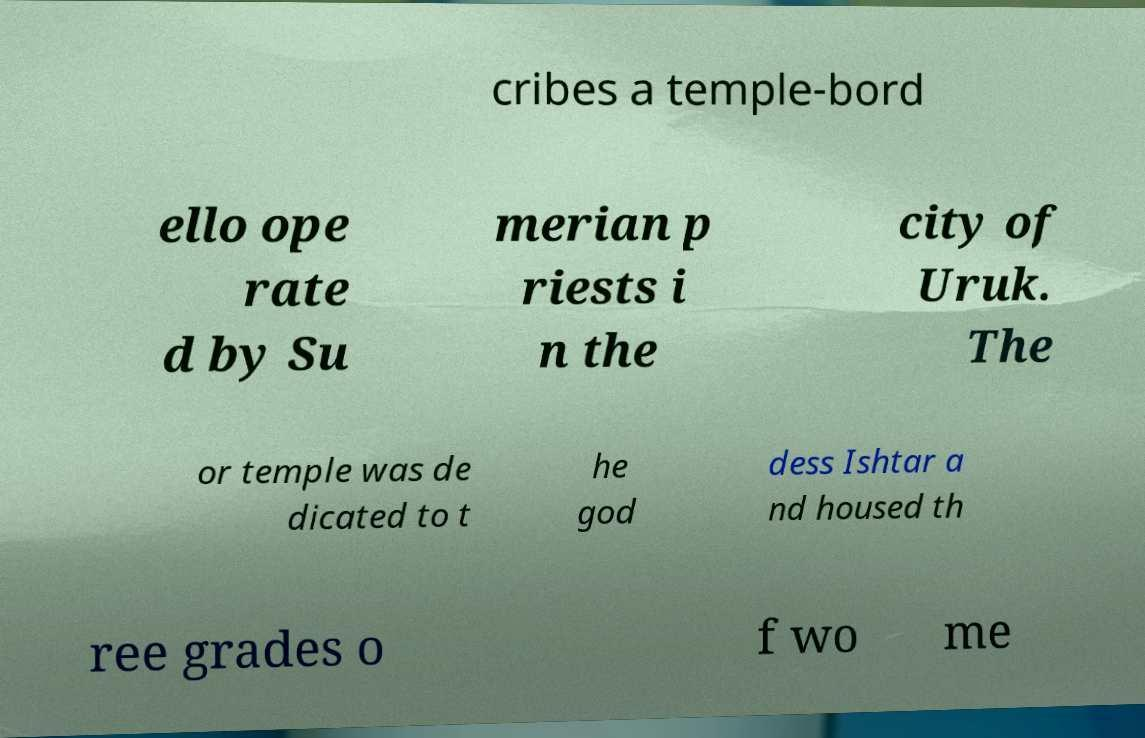I need the written content from this picture converted into text. Can you do that? cribes a temple-bord ello ope rate d by Su merian p riests i n the city of Uruk. The or temple was de dicated to t he god dess Ishtar a nd housed th ree grades o f wo me 